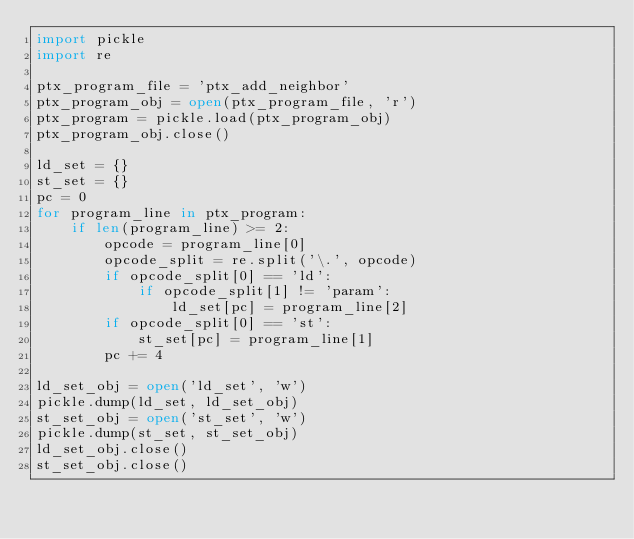Convert code to text. <code><loc_0><loc_0><loc_500><loc_500><_Python_>import pickle
import re

ptx_program_file = 'ptx_add_neighbor'
ptx_program_obj = open(ptx_program_file, 'r')
ptx_program = pickle.load(ptx_program_obj)
ptx_program_obj.close()

ld_set = {}
st_set = {}
pc = 0
for program_line in ptx_program:
    if len(program_line) >= 2:
        opcode = program_line[0]
        opcode_split = re.split('\.', opcode)
        if opcode_split[0] == 'ld':
            if opcode_split[1] != 'param':
                ld_set[pc] = program_line[2] 
        if opcode_split[0] == 'st':
            st_set[pc] = program_line[1]
        pc += 4

ld_set_obj = open('ld_set', 'w')
pickle.dump(ld_set, ld_set_obj)
st_set_obj = open('st_set', 'w')
pickle.dump(st_set, st_set_obj)
ld_set_obj.close()
st_set_obj.close()



</code> 